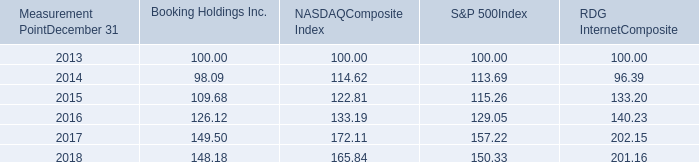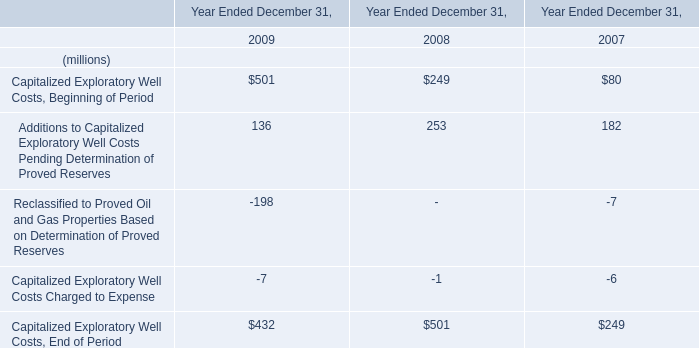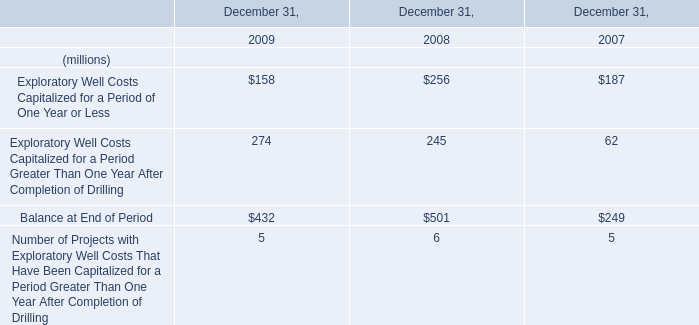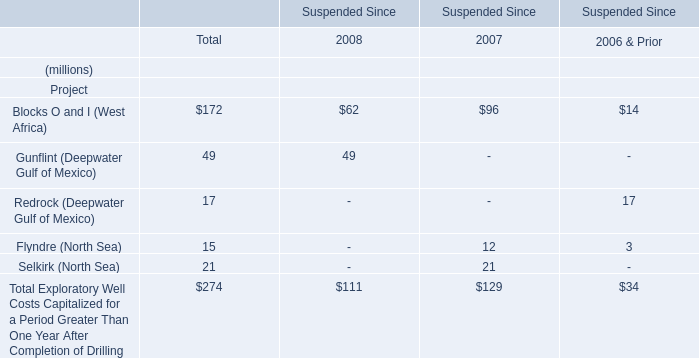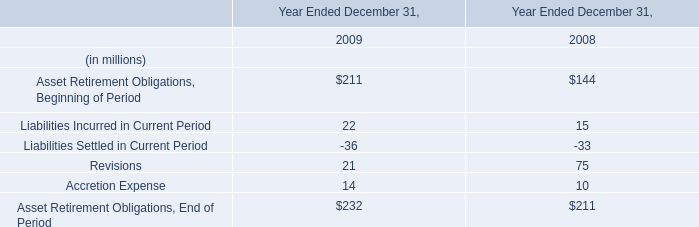Which year is Blocks O and I (West Africa) the most? 
Answer: 2007. 